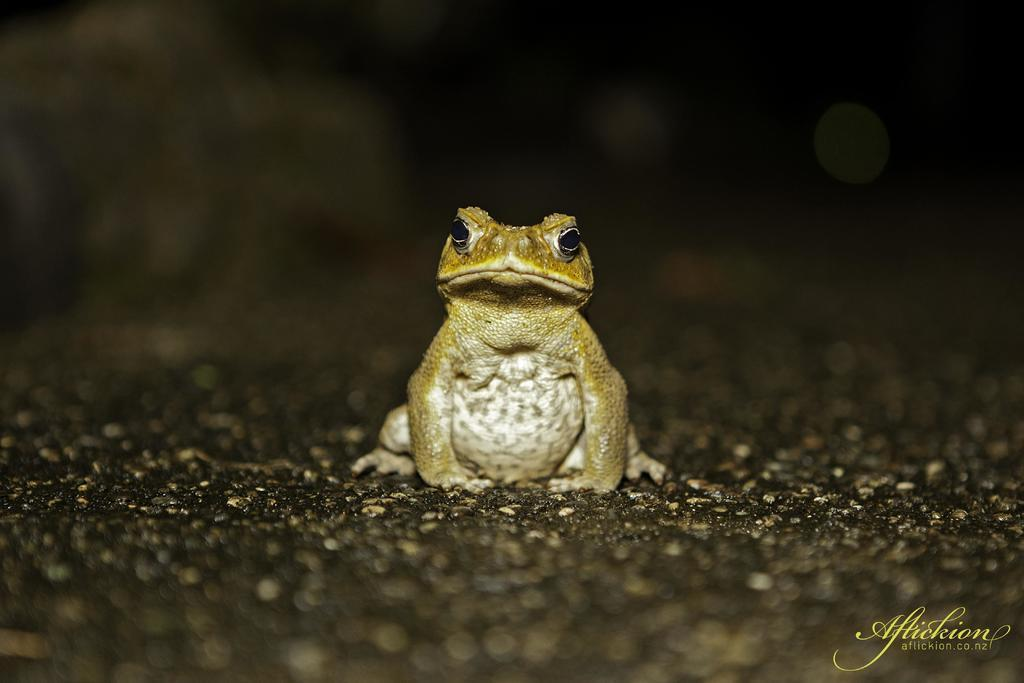What animal is present in the image? There is a frog in the image. Where is the frog located in the image? The frog is on the ground. Is there any text or label in the image? Yes, there is a name in the bottom right corner of the image. What type of plantation can be seen in the image? There is no plantation present in the image; it features a frog on the ground. How many arms does the frog have in the image? Frogs have four limbs, but they are not referred to as arms; they have two front limbs and two hind limbs. 